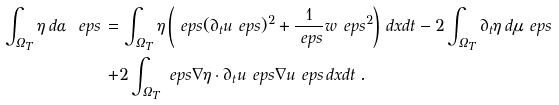Convert formula to latex. <formula><loc_0><loc_0><loc_500><loc_500>\int _ { \Omega _ { T } } \eta \, d \alpha _ { \ } e p s \, = & \, \int _ { \Omega _ { T } } \eta \left ( \ e p s ( \partial _ { t } u _ { \ } e p s ) ^ { 2 } + \frac { 1 } { \ e p s } w _ { \ } e p s ^ { 2 } \right ) \, d x d t - 2 \int _ { \Omega _ { T } } \partial _ { t } \eta \, d \mu _ { \ } e p s \\ + & 2 \int _ { \Omega _ { T } } \ e p s \nabla \eta \cdot \partial _ { t } u _ { \ } e p s \nabla u _ { \ } e p s \, d x d t \, .</formula> 